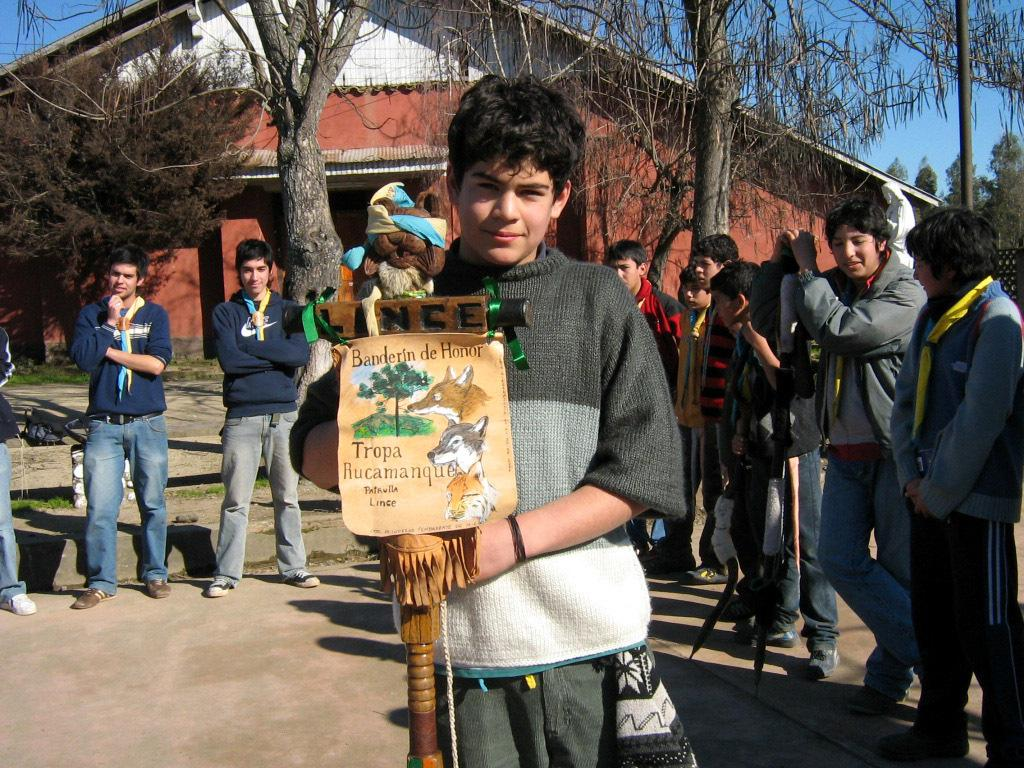What are the people in the image doing? There is a group of people standing on the ground in the image. What can be seen on a wall or surface in the image? There is a poster in the image. What type of object is present in the image? There is a toy in the image. What type of structure is visible in the image? There is a building in the image. What type of vegetation is present in the image? There are trees in the image. What other objects can be seen in the image? There are some objects in the image. What is visible in the background of the image? The sky is visible in the background of the image. Can you tell me how many boats are participating in the feast in the image? There is no boat or feast present in the image. What type of shade is provided by the trees in the image? There is no mention of shade in the image, as the focus is on the people, poster, toy, building, objects, and sky. 